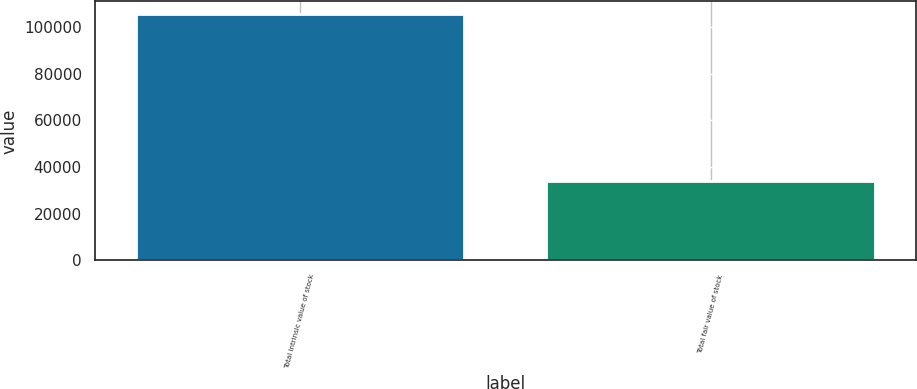Convert chart. <chart><loc_0><loc_0><loc_500><loc_500><bar_chart><fcel>Total intrinsic value of stock<fcel>Total fair value of stock<nl><fcel>105756<fcel>33932<nl></chart> 